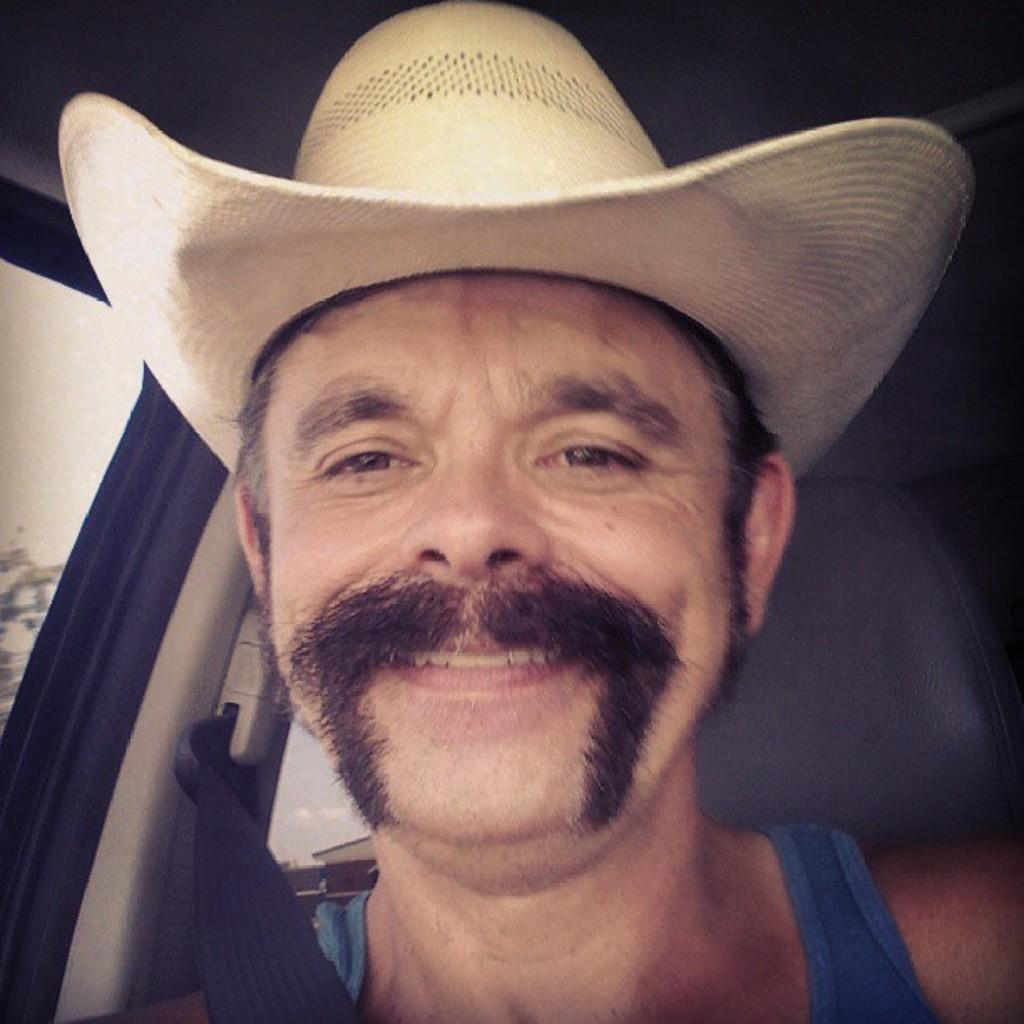What can be seen in the image? There is a person in the image. What is the person wearing on their head? The person is wearing a white hat. What type of clothing is the person wearing on their upper body? The person is wearing a blue vest. Where is the person located in the image? The person is sitting in a car. What can be seen in the background of the image? There is a car seat visible in the background of the image. What type of guitar is the person playing in the image? There is no guitar present in the image; the person is sitting in a car. Who is the manager of the person in the image? There is no information about a manager in the image or the provided facts. 